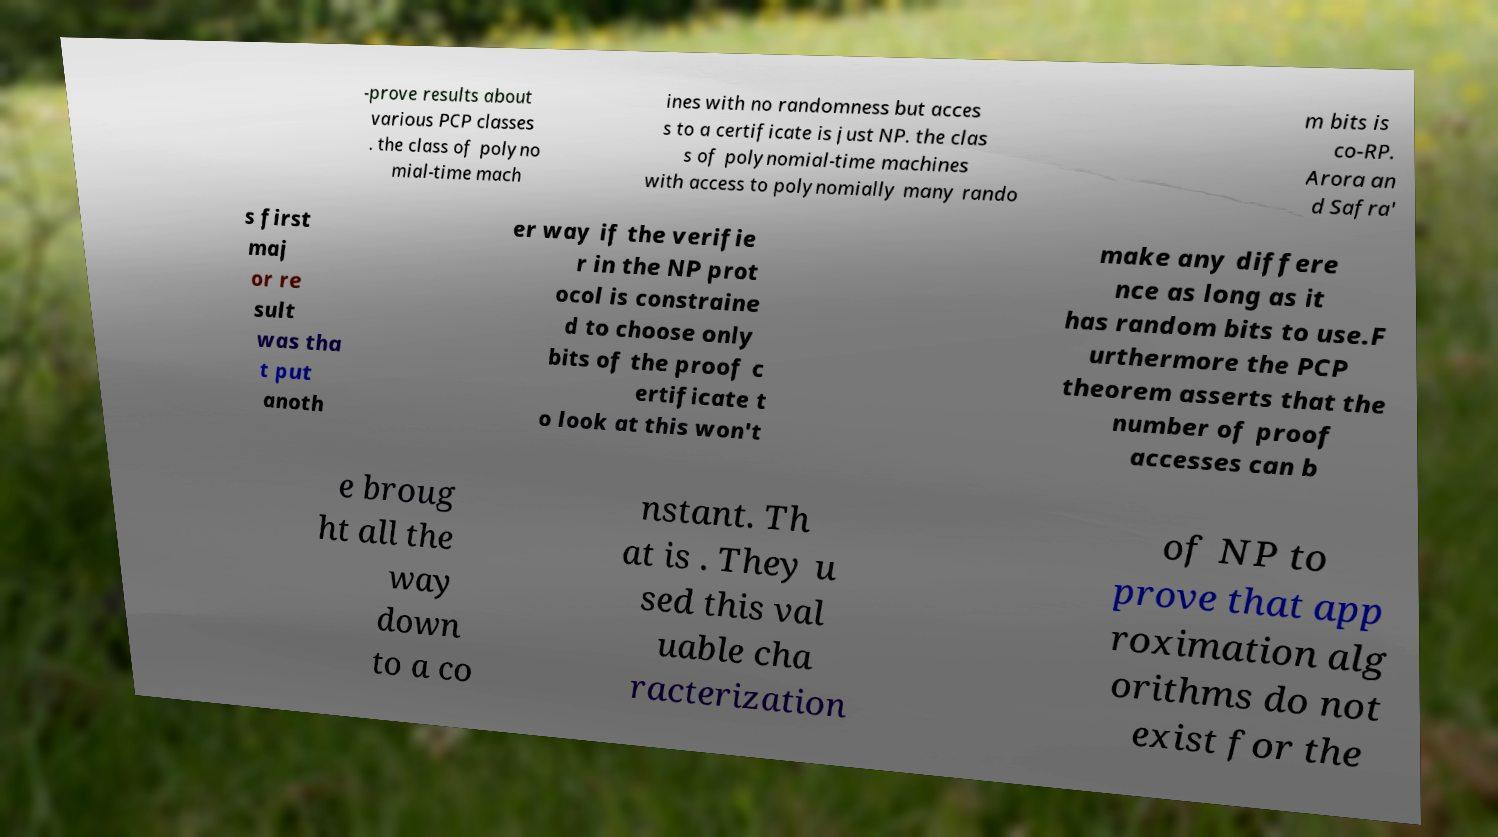Could you extract and type out the text from this image? -prove results about various PCP classes . the class of polyno mial-time mach ines with no randomness but acces s to a certificate is just NP. the clas s of polynomial-time machines with access to polynomially many rando m bits is co-RP. Arora an d Safra' s first maj or re sult was tha t put anoth er way if the verifie r in the NP prot ocol is constraine d to choose only bits of the proof c ertificate t o look at this won't make any differe nce as long as it has random bits to use.F urthermore the PCP theorem asserts that the number of proof accesses can b e broug ht all the way down to a co nstant. Th at is . They u sed this val uable cha racterization of NP to prove that app roximation alg orithms do not exist for the 